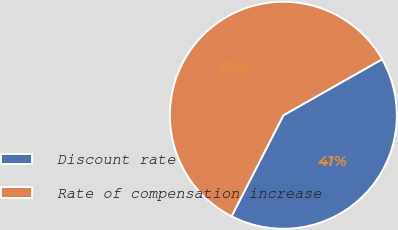Convert chart. <chart><loc_0><loc_0><loc_500><loc_500><pie_chart><fcel>Discount rate<fcel>Rate of compensation increase<nl><fcel>40.76%<fcel>59.24%<nl></chart> 